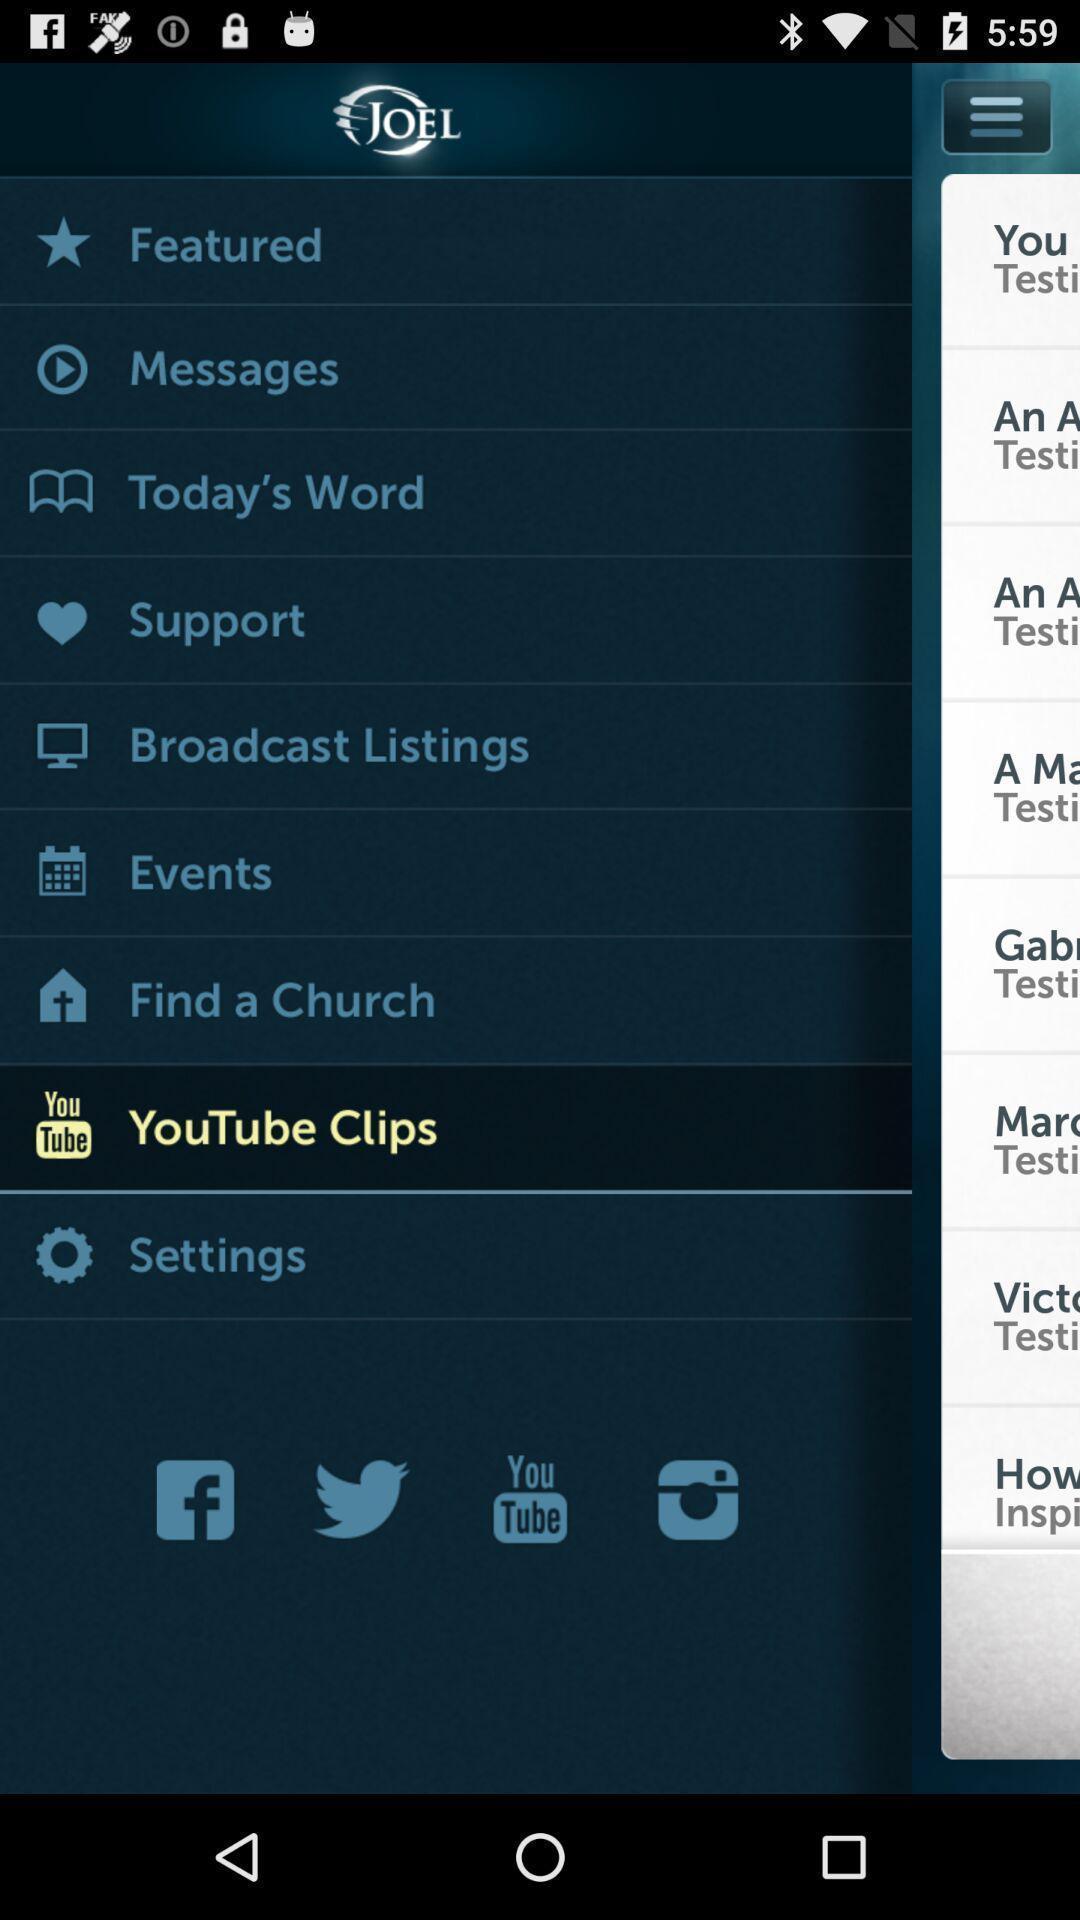Explain the elements present in this screenshot. Various types of tabs in the application. 